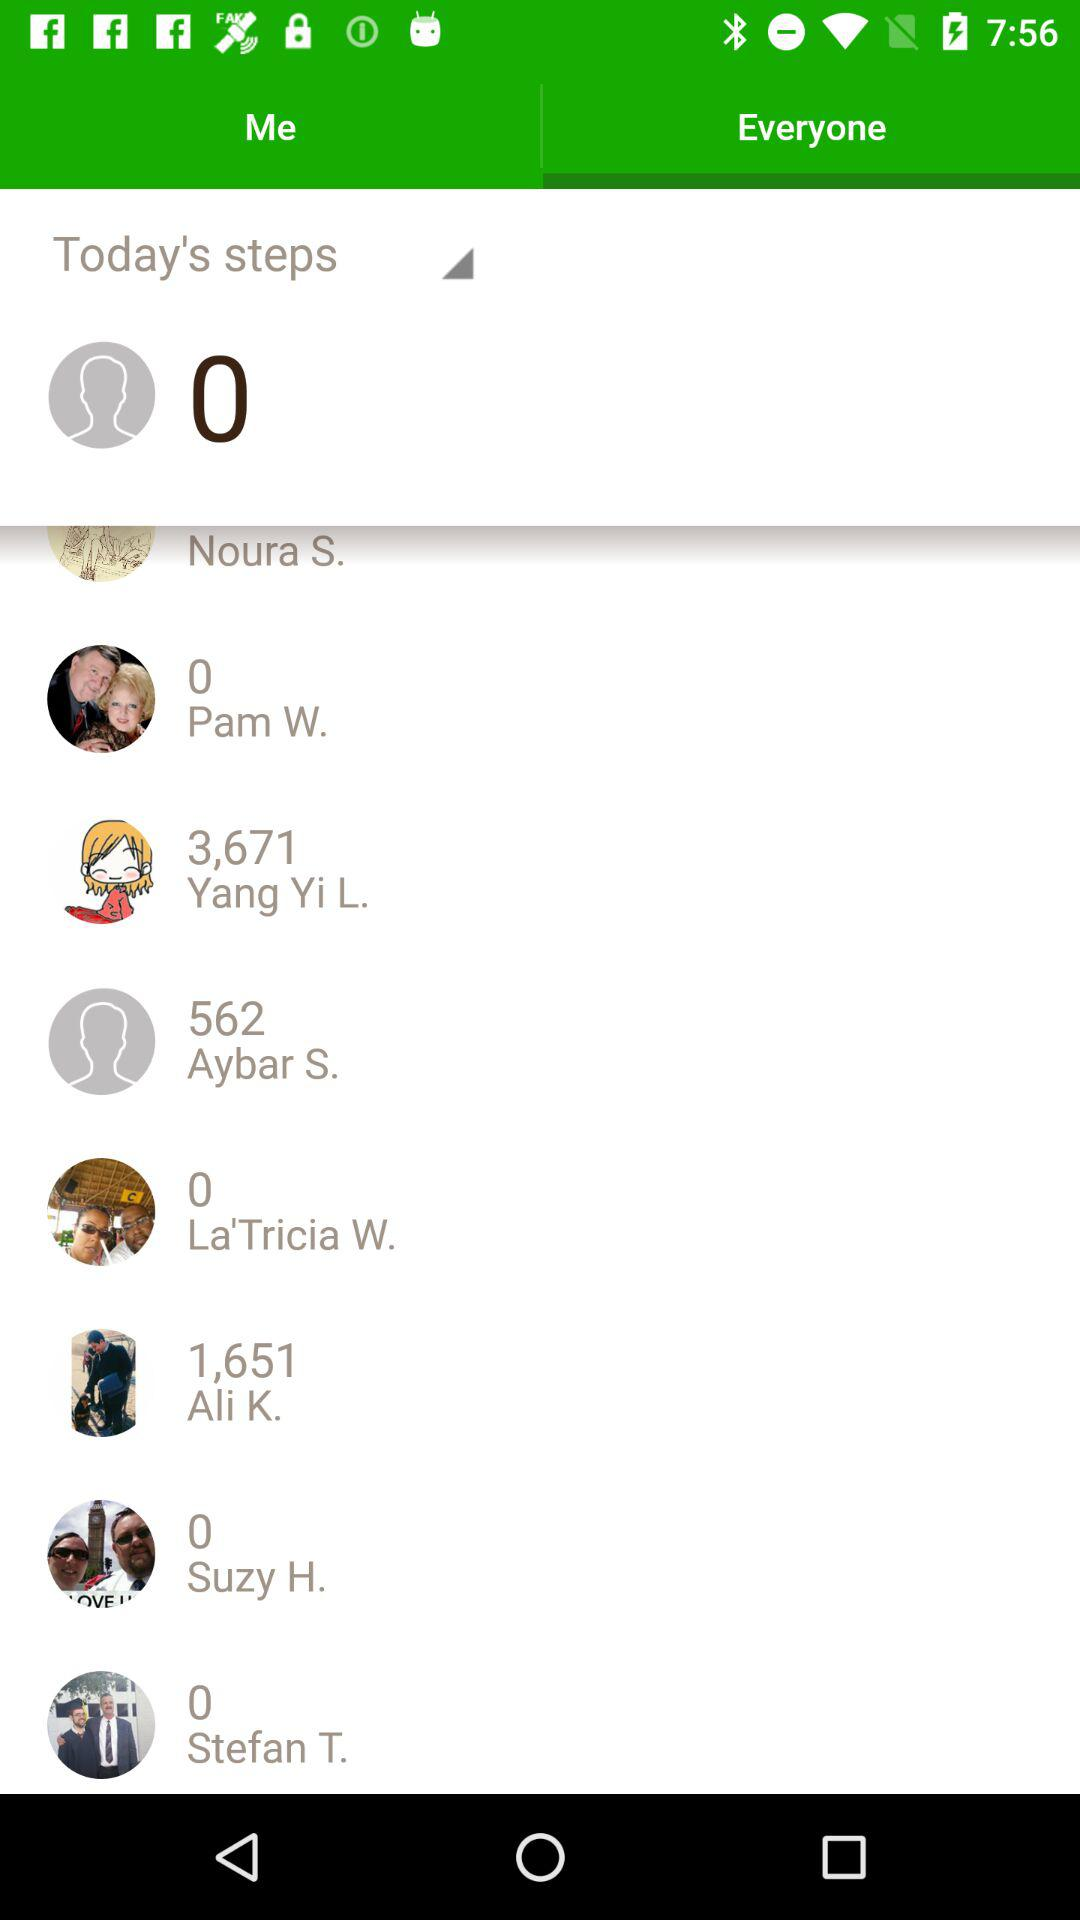How many steps in total were taken by Ali K.? Ali K. took 1,651 steps in total. 